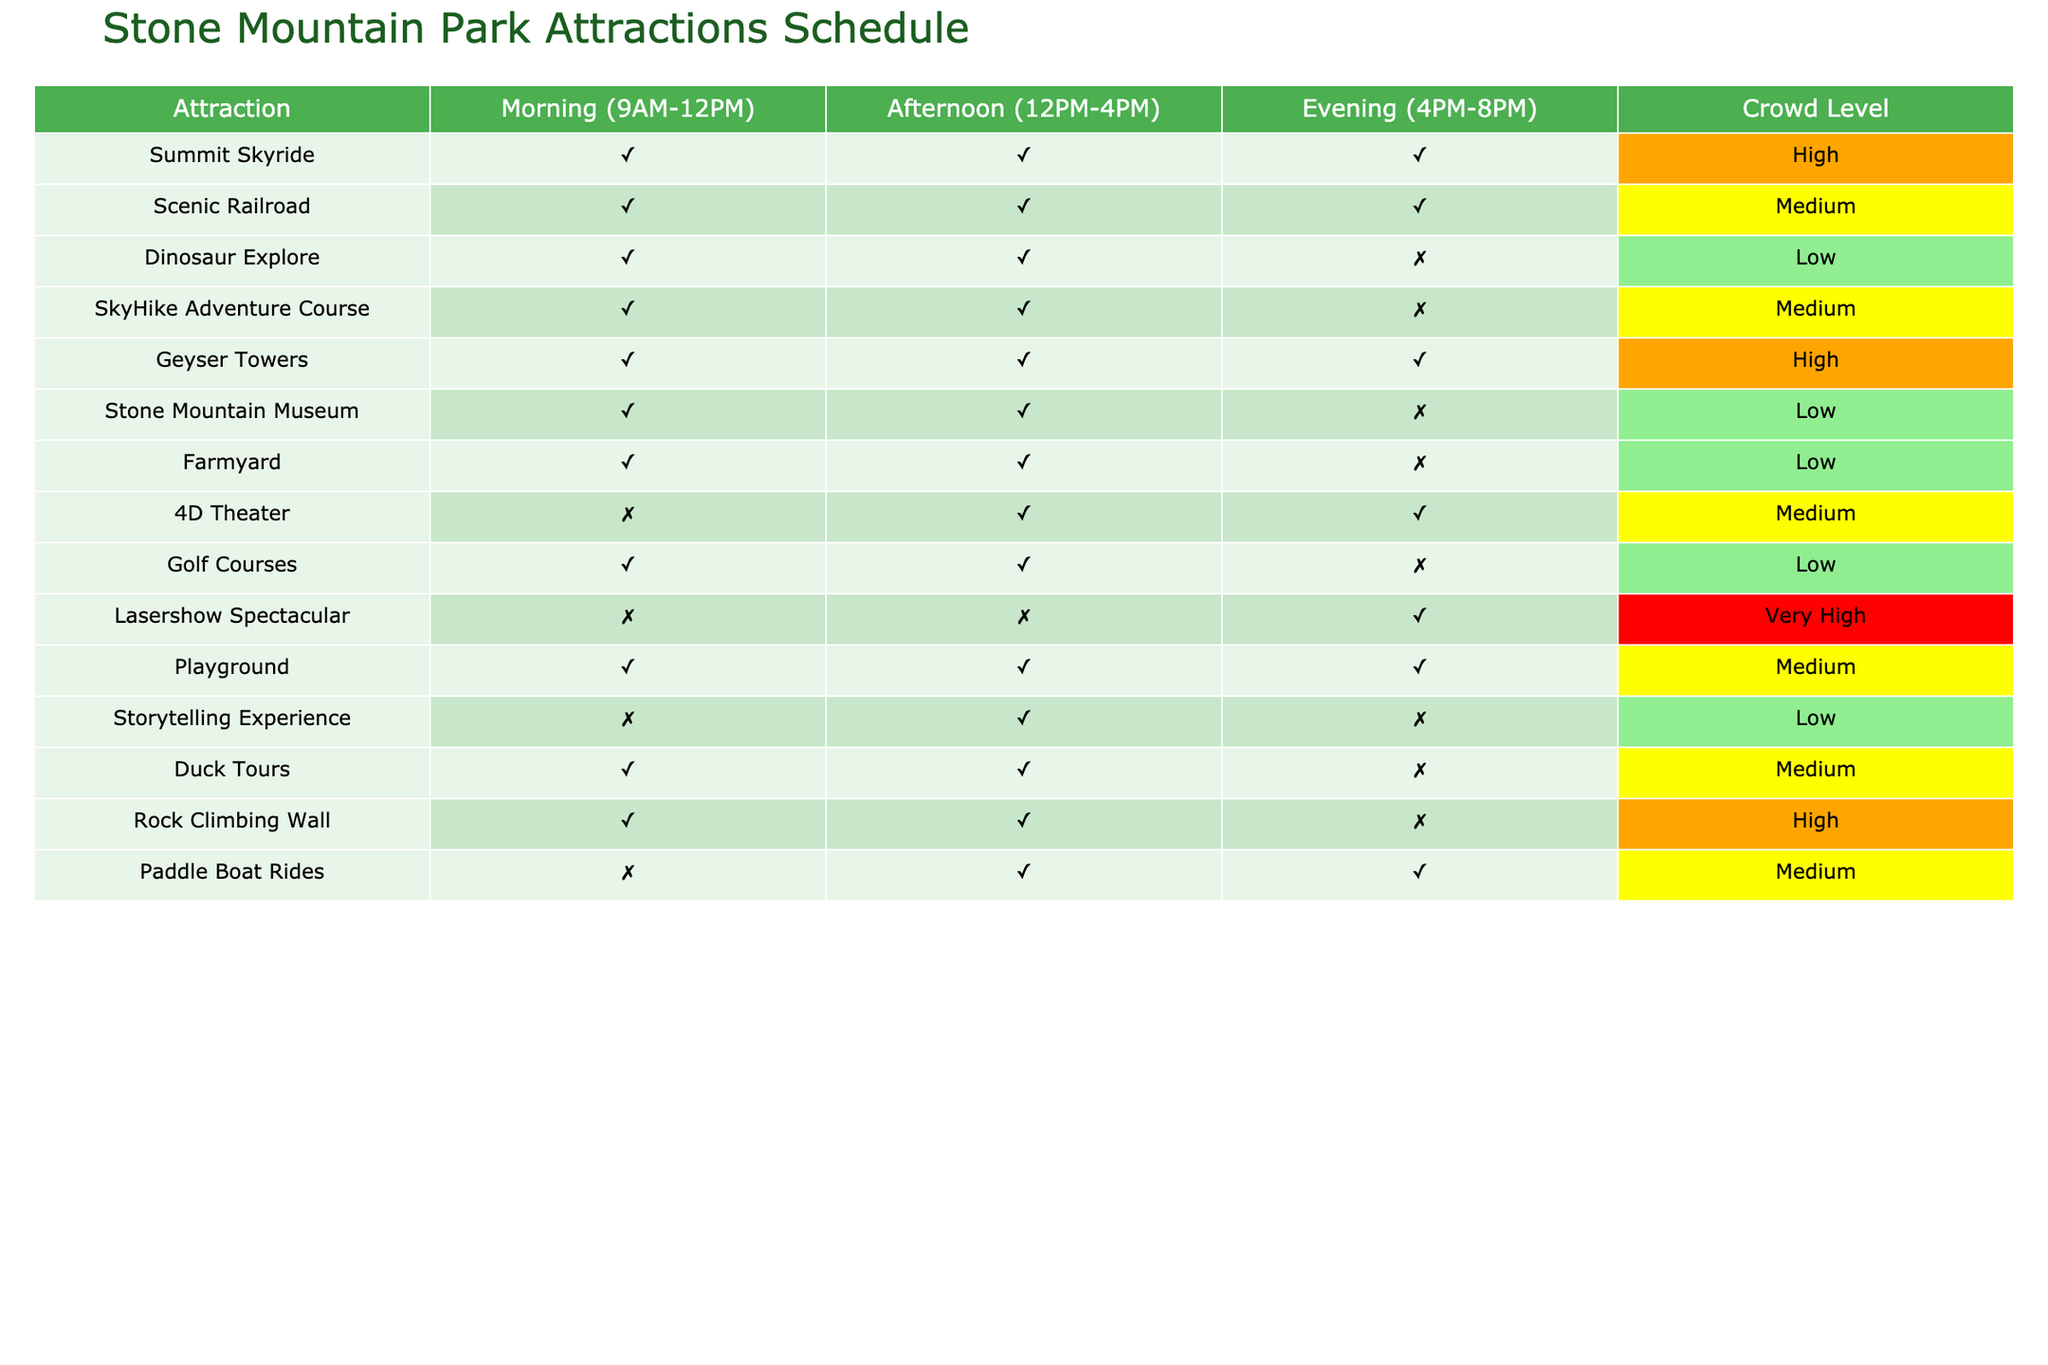What attractions are open in the morning? The table states the status of attractions in the morning (9AM-12PM). We can look down the "Morning (9AM-12PM)" column and see which entries say "Open." These attractions are Summit Skyride, Scenic Railroad, Dinosaur Explore, SkyHike Adventure Course, Geyser Towers, Stone Mountain Museum, Farmyard, 4D Theater, Golf Courses, Playground, Duck Tours, and Rock Climbing Wall.
Answer: 12 attractions What is the crowd level for the Lasershow Spectacular? According to the table, the Lasershow Spectacular is marked with "Very High" under the "Crowd Level" column. This value indicates that it expects a significant number of visitors during the specified times.
Answer: Very High How many attractions close by the evening? We will check the "Evening (4PM-8PM)" column for any attractions marked "Closed." The attractions that are closed in the evening are Dinosaur Explore, Stone Mountain Museum, SkyHike Adventure Course, and Rock Climbing Wall, making a total of 4 attractions closed during this time.
Answer: 4 attractions Which attraction has the highest crowd level in the afternoon? We need to identify the crowd levels in the "Crowd Level" column for the afternoon period. The maximum level is "High," associated with Summit Skyride and Geyser Towers. Since both have the same crowd level, we can still say both attractions experience high crowds in the afternoon.
Answer: Summit Skyride and Geyser Towers Is the Duck Tours available all day? To find this, we can check the "Open" status for Duck Tours in all three time slots. It shows "Open" both morning and afternoon, but "Closed" in the evening. Therefore, Duck Tours is not available all day.
Answer: No What is the total number of attractions that open in the afternoon but close in the evening? We inspect the "Afternoon (12PM-4PM)" column for attractions marked "Open" and then check the "Evening (4PM-8PM)" column for the same attractions marked "Closed." The attractions fitting this criteria are Duck Tours, 4D Theater, SkyHike Adventure Course, and Rock Climbing Wall, leading to a total of 4 attractions that open in the afternoon but close at night.
Answer: 4 attractions Are there any activities available in the morning that are closed in the evening? We look at both the "Morning (9AM-12PM)" and "Evening (4PM-8PM)" columns. The attractions that are open in the morning and closed by evening are Dinosaur Explore, Stone Mountain Museum, SkyHike Adventure Course, and Rock Climbing Wall. Therefore, there are 4 attractions that fit this description.
Answer: 4 attractions What is the average crowd level for the attractions open in the afternoon? First, we identify the attractions that are open in the afternoon: Summit Skyride, Scenic Railroad, Geyser Towers, Duck Tours, Playground, and 4D Theater. Next, we note their crowd levels: High, Medium, High, Medium, Medium; translating these to numerical values (High=3, Medium=2, Low=1) gives us 3, 2, 3, 2, 2. The total is 12 and dividing by 5 attractions gives us an average crowd level of 2.4, which corresponds to Medium.
Answer: Medium 